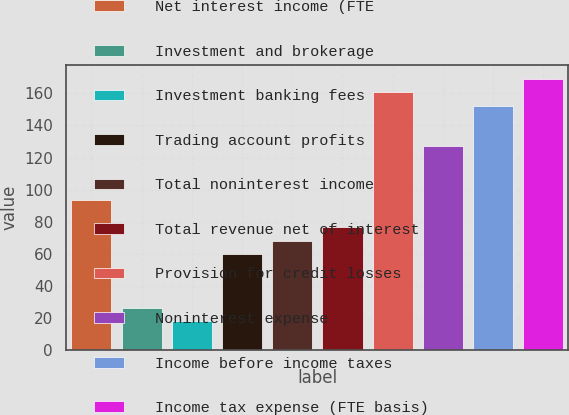<chart> <loc_0><loc_0><loc_500><loc_500><bar_chart><fcel>Net interest income (FTE<fcel>Investment and brokerage<fcel>Investment banking fees<fcel>Trading account profits<fcel>Total noninterest income<fcel>Total revenue net of interest<fcel>Provision for credit losses<fcel>Noninterest expense<fcel>Income before income taxes<fcel>Income tax expense (FTE basis)<nl><fcel>93.4<fcel>26.2<fcel>17.8<fcel>59.8<fcel>68.2<fcel>76.6<fcel>160.6<fcel>127<fcel>152.2<fcel>169<nl></chart> 